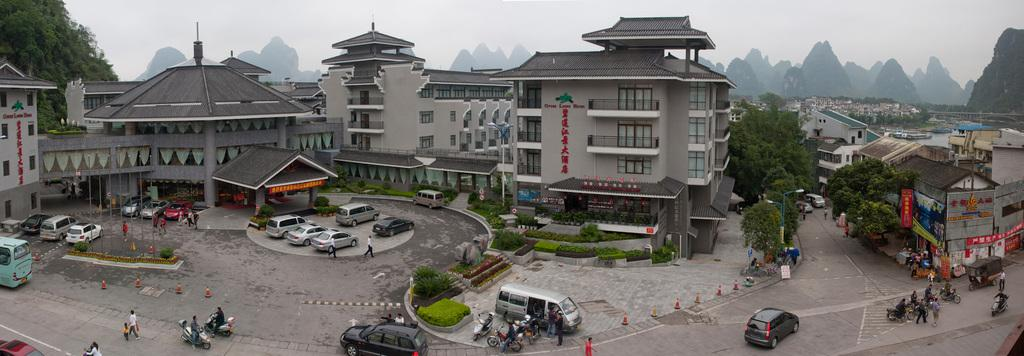What can be seen on the road in the image? There are vehicles on the road in the image. What objects are present to guide or control traffic? Traffic cones are present in the image. What vertical structures can be seen in the image? Poles are visible in the image. What type of vegetation is present in the image? Plants are present in the image. What flat, rectangular objects can be seen in the image? Boards are visible in the image. What type of man-made structures are present in the image? Buildings are present in the image. Are there any human figures in the image? Yes, there are people in the image. What is visible in the background of the image? The sky is visible in the background of the image. Where is the library located in the image? There is no library present in the image. What type of comfort can be seen being provided by the vehicles in the image? The vehicles in the image do not provide comfort; they are simply moving or parked on the road. 